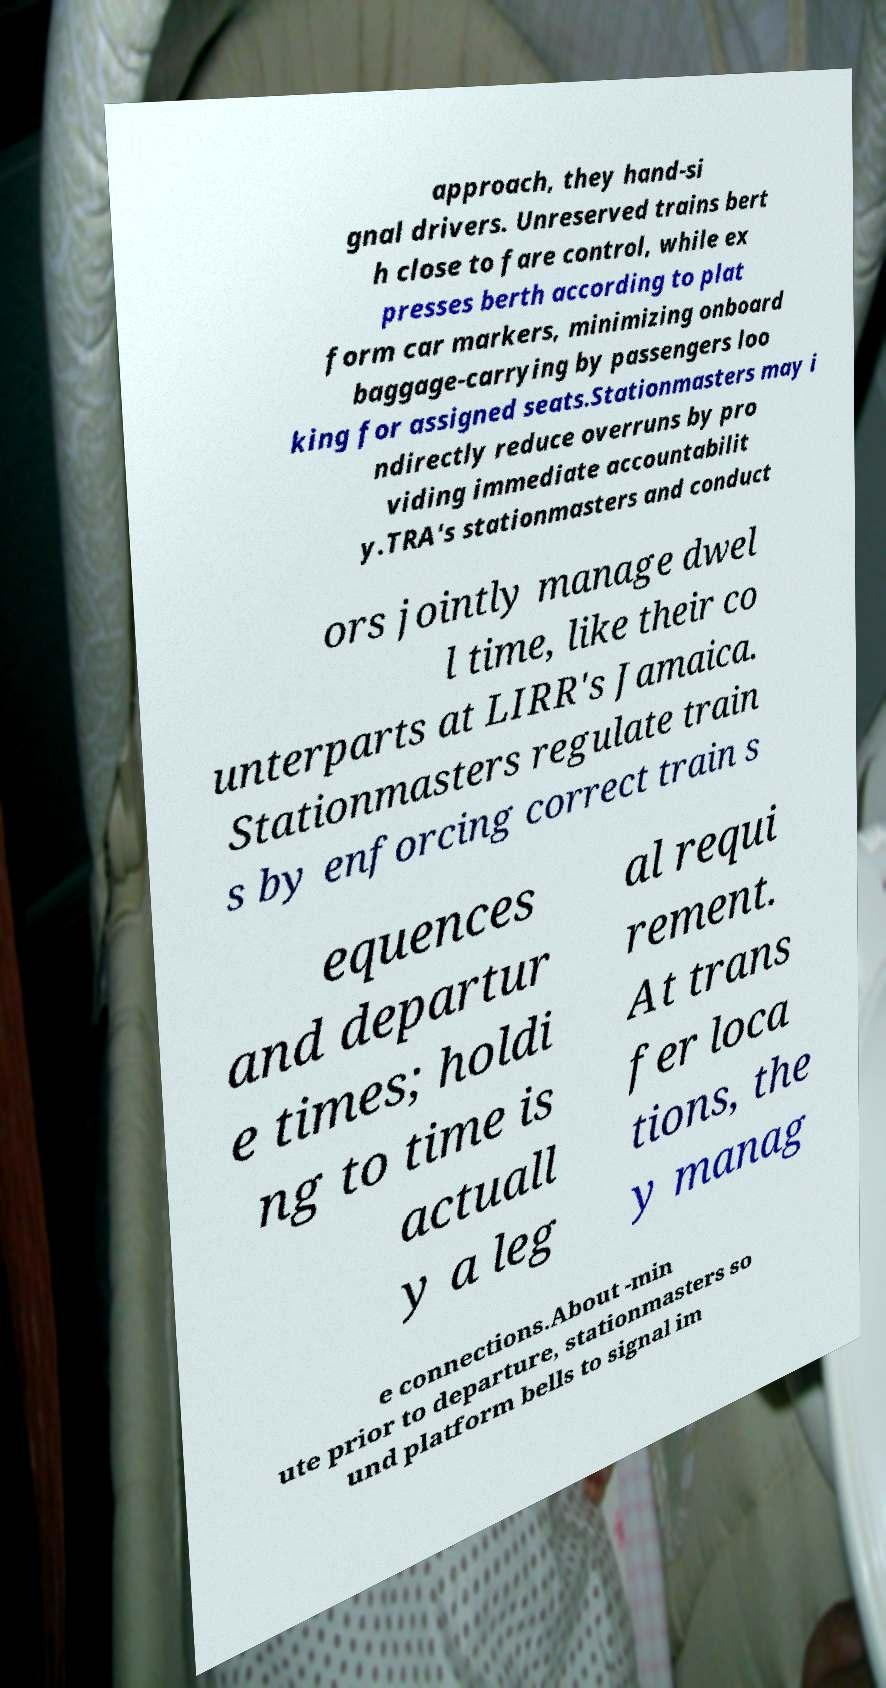Can you accurately transcribe the text from the provided image for me? approach, they hand-si gnal drivers. Unreserved trains bert h close to fare control, while ex presses berth according to plat form car markers, minimizing onboard baggage-carrying by passengers loo king for assigned seats.Stationmasters may i ndirectly reduce overruns by pro viding immediate accountabilit y.TRA's stationmasters and conduct ors jointly manage dwel l time, like their co unterparts at LIRR's Jamaica. Stationmasters regulate train s by enforcing correct train s equences and departur e times; holdi ng to time is actuall y a leg al requi rement. At trans fer loca tions, the y manag e connections.About -min ute prior to departure, stationmasters so und platform bells to signal im 